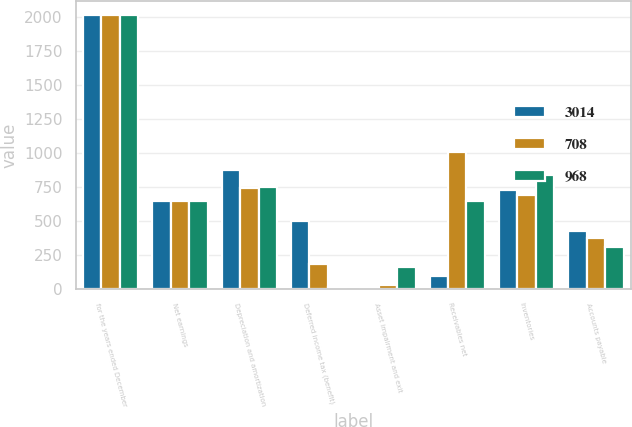Convert chart to OTSL. <chart><loc_0><loc_0><loc_500><loc_500><stacked_bar_chart><ecel><fcel>for the years ended December<fcel>Net earnings<fcel>Depreciation and amortization<fcel>Deferred income tax (benefit)<fcel>Asset impairment and exit<fcel>Receivables net<fcel>Inventories<fcel>Accounts payable<nl><fcel>3014<fcel>2017<fcel>647<fcel>875<fcel>501<fcel>10<fcel>92<fcel>730<fcel>425<nl><fcel>708<fcel>2016<fcel>647<fcel>743<fcel>182<fcel>31<fcel>1009<fcel>695<fcel>373<nl><fcel>968<fcel>2015<fcel>647<fcel>754<fcel>18<fcel>164<fcel>647<fcel>841<fcel>310<nl></chart> 